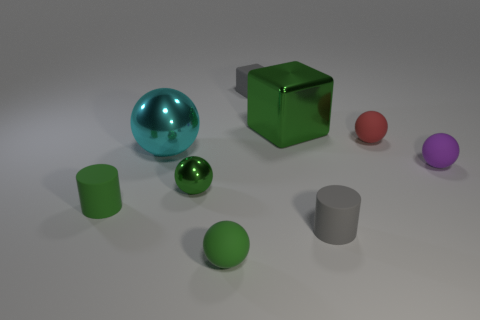Subtract all red rubber spheres. How many spheres are left? 4 Subtract all gray spheres. Subtract all purple cylinders. How many spheres are left? 5 Add 1 purple spheres. How many objects exist? 10 Subtract all blocks. How many objects are left? 7 Add 5 big balls. How many big balls are left? 6 Add 7 small brown balls. How many small brown balls exist? 7 Subtract 0 brown balls. How many objects are left? 9 Subtract all green rubber things. Subtract all small green metal objects. How many objects are left? 6 